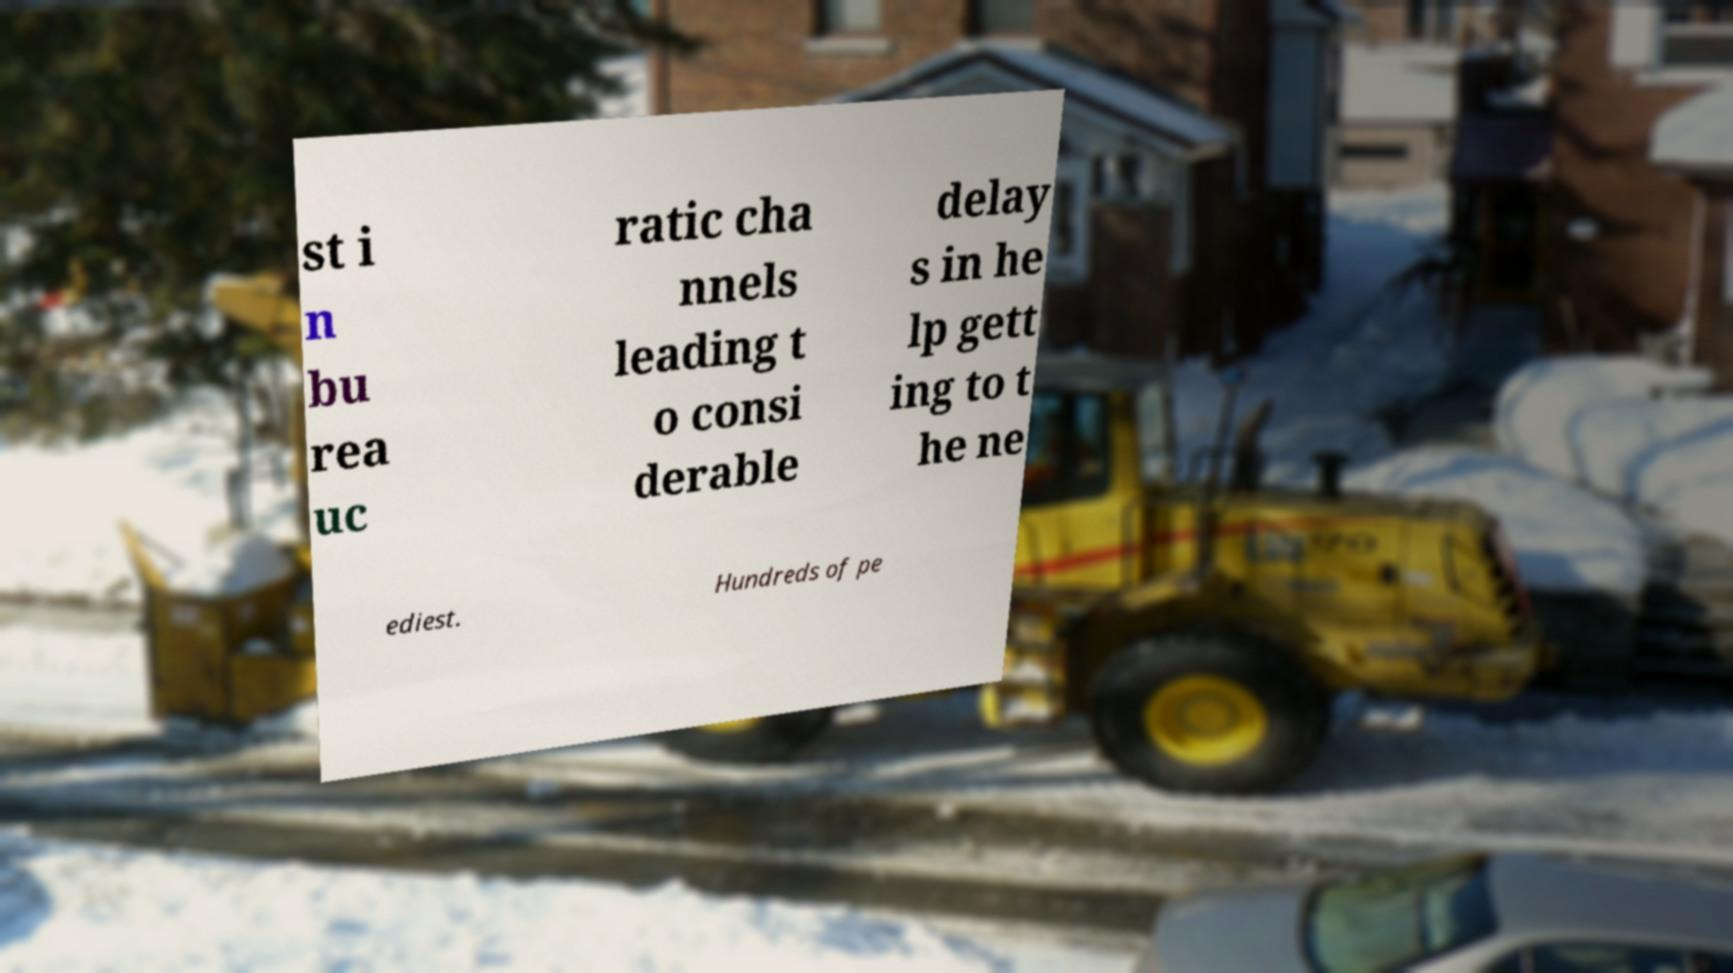Can you read and provide the text displayed in the image?This photo seems to have some interesting text. Can you extract and type it out for me? st i n bu rea uc ratic cha nnels leading t o consi derable delay s in he lp gett ing to t he ne ediest. Hundreds of pe 